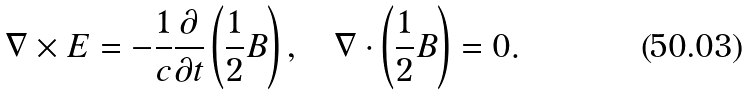<formula> <loc_0><loc_0><loc_500><loc_500>\nabla \times { E } = - \frac { 1 } { c } \frac { \partial } { \partial t } \left ( \frac { 1 } { 2 } { B } \right ) , \quad \nabla \cdot \left ( \frac { 1 } { 2 } { B } \right ) = 0 .</formula> 